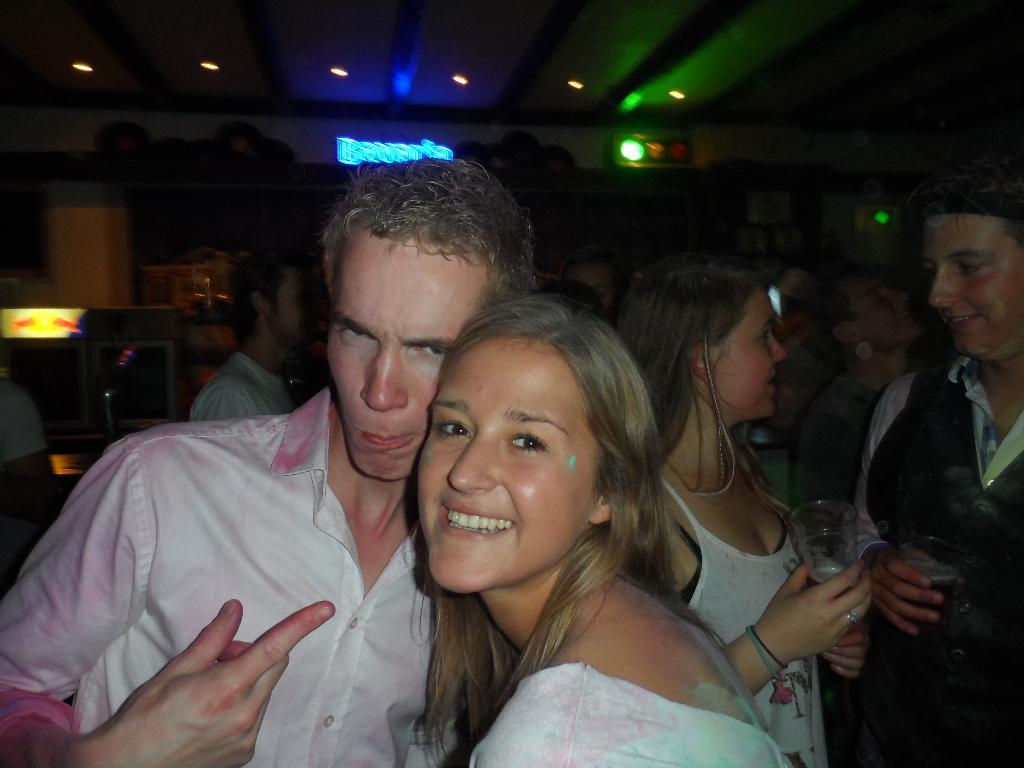How many people are in the image? There are people in the image. What are two people doing in the image? Two people are holding glasses in the image. What can be seen in the image that provides illumination? There are lights in the image. What is the design of the knowledge displayed in the image? There is no knowledge displayed in the image, and therefore no design can be determined. 